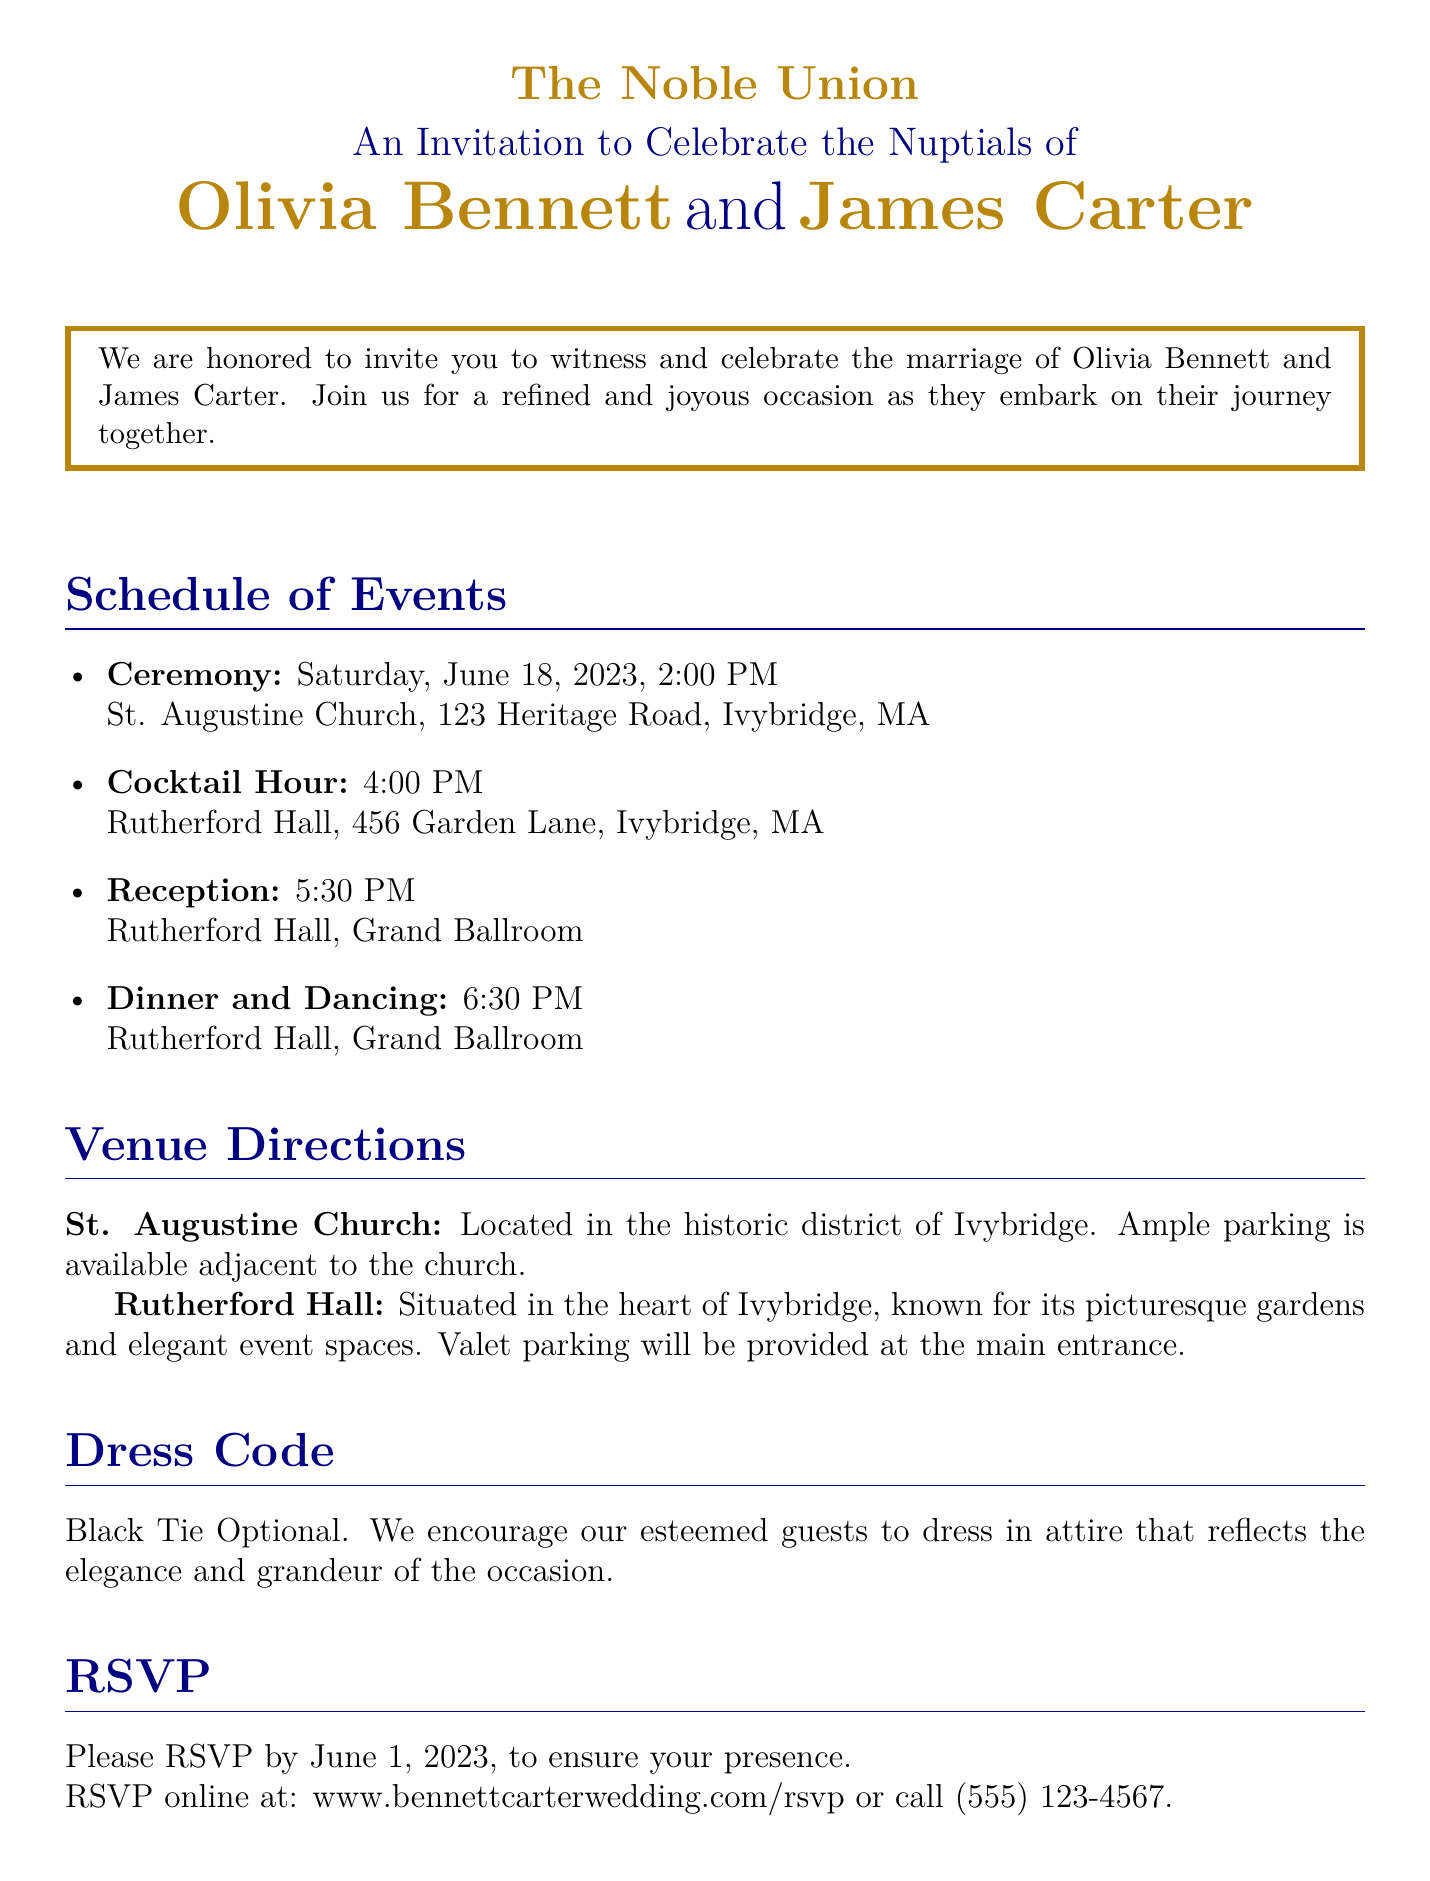What is the date of the ceremony? The date of the ceremony is directly stated in the document as June 18, 2023.
Answer: June 18, 2023 Who are the couple getting married? The names of the couple are provided prominently in the document.
Answer: Olivia Bennett and James Carter What time does the cocktail hour begin? The document specifies the time for the cocktail hour under the schedule of events.
Answer: 4:00 PM Where is the reception taking place? The venue for the reception is detailed in the schedule of events section.
Answer: Rutherford Hall, Grand Ballroom What is the RSVP deadline? The deadline for RSVPing is clearly stated in the RSVP section of the document.
Answer: June 1, 2023 What type of dress code is suggested? The document includes a dress code section that outlines what is expected of guests.
Answer: Black Tie Optional How is parking handled at Rutherford Hall? The document mentions valet parking provision at Rutherford Hall, which addresses parking arrangements.
Answer: Valet parking What is the purpose of the framing around the text? The use of framed text is a stylistic choice to highlight key information about the event, emphasizing its importance.
Answer: Elegance How is the wedding described in terms of atmosphere? The invitation uses specific language to convey a sense of refinement and joy for the occasion.
Answer: Refined and joyous 